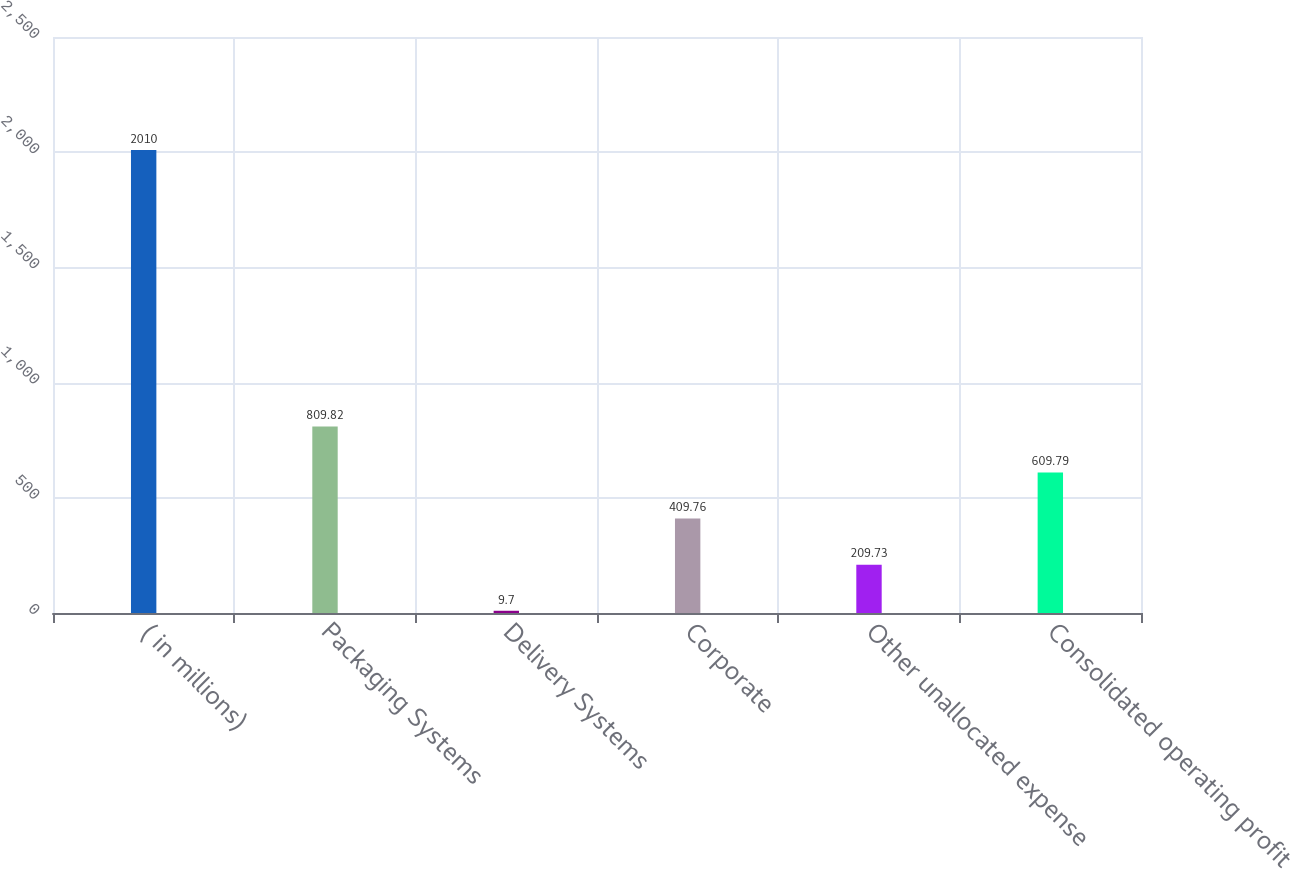Convert chart to OTSL. <chart><loc_0><loc_0><loc_500><loc_500><bar_chart><fcel>( in millions)<fcel>Packaging Systems<fcel>Delivery Systems<fcel>Corporate<fcel>Other unallocated expense<fcel>Consolidated operating profit<nl><fcel>2010<fcel>809.82<fcel>9.7<fcel>409.76<fcel>209.73<fcel>609.79<nl></chart> 